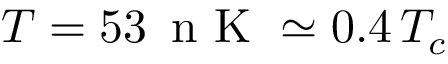<formula> <loc_0><loc_0><loc_500><loc_500>T = 5 3 \, n K \simeq 0 . 4 \, T _ { c }</formula> 